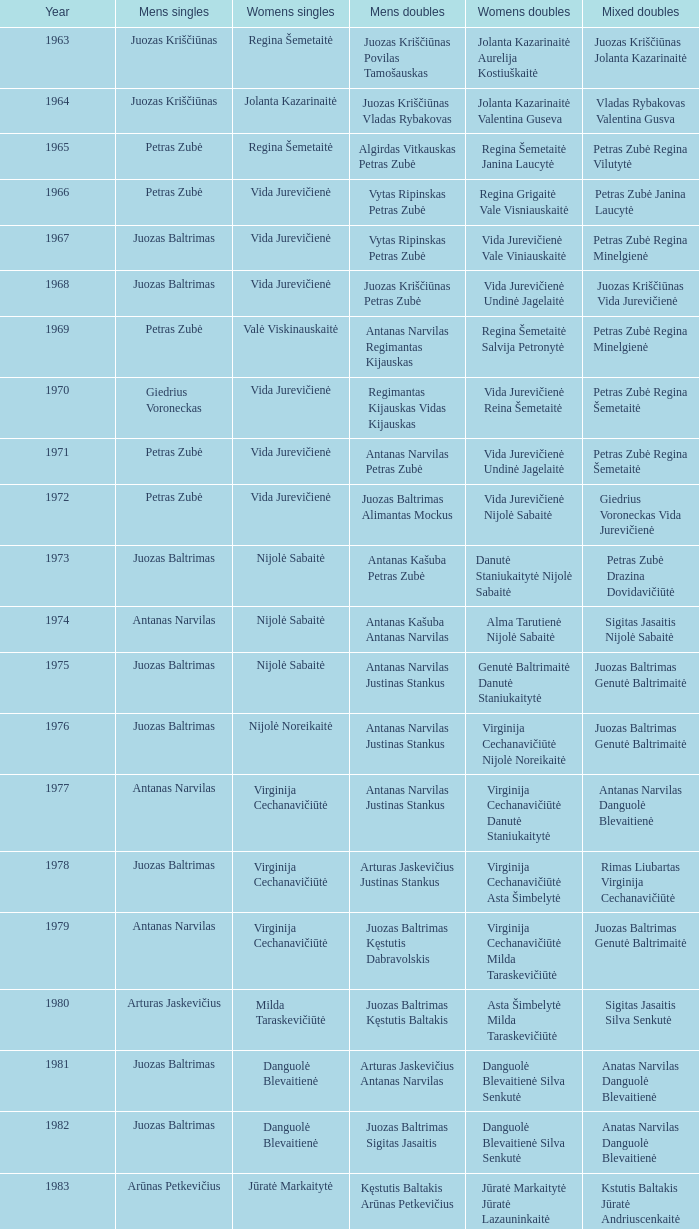In which year did the lithuanian national badminton championships commence? 1963.0. Can you give me this table as a dict? {'header': ['Year', 'Mens singles', 'Womens singles', 'Mens doubles', 'Womens doubles', 'Mixed doubles'], 'rows': [['1963', 'Juozas Kriščiūnas', 'Regina Šemetaitė', 'Juozas Kriščiūnas Povilas Tamošauskas', 'Jolanta Kazarinaitė Aurelija Kostiuškaitė', 'Juozas Kriščiūnas Jolanta Kazarinaitė'], ['1964', 'Juozas Kriščiūnas', 'Jolanta Kazarinaitė', 'Juozas Kriščiūnas Vladas Rybakovas', 'Jolanta Kazarinaitė Valentina Guseva', 'Vladas Rybakovas Valentina Gusva'], ['1965', 'Petras Zubė', 'Regina Šemetaitė', 'Algirdas Vitkauskas Petras Zubė', 'Regina Šemetaitė Janina Laucytė', 'Petras Zubė Regina Vilutytė'], ['1966', 'Petras Zubė', 'Vida Jurevičienė', 'Vytas Ripinskas Petras Zubė', 'Regina Grigaitė Vale Visniauskaitė', 'Petras Zubė Janina Laucytė'], ['1967', 'Juozas Baltrimas', 'Vida Jurevičienė', 'Vytas Ripinskas Petras Zubė', 'Vida Jurevičienė Vale Viniauskaitė', 'Petras Zubė Regina Minelgienė'], ['1968', 'Juozas Baltrimas', 'Vida Jurevičienė', 'Juozas Kriščiūnas Petras Zubė', 'Vida Jurevičienė Undinė Jagelaitė', 'Juozas Kriščiūnas Vida Jurevičienė'], ['1969', 'Petras Zubė', 'Valė Viskinauskaitė', 'Antanas Narvilas Regimantas Kijauskas', 'Regina Šemetaitė Salvija Petronytė', 'Petras Zubė Regina Minelgienė'], ['1970', 'Giedrius Voroneckas', 'Vida Jurevičienė', 'Regimantas Kijauskas Vidas Kijauskas', 'Vida Jurevičienė Reina Šemetaitė', 'Petras Zubė Regina Šemetaitė'], ['1971', 'Petras Zubė', 'Vida Jurevičienė', 'Antanas Narvilas Petras Zubė', 'Vida Jurevičienė Undinė Jagelaitė', 'Petras Zubė Regina Šemetaitė'], ['1972', 'Petras Zubė', 'Vida Jurevičienė', 'Juozas Baltrimas Alimantas Mockus', 'Vida Jurevičienė Nijolė Sabaitė', 'Giedrius Voroneckas Vida Jurevičienė'], ['1973', 'Juozas Baltrimas', 'Nijolė Sabaitė', 'Antanas Kašuba Petras Zubė', 'Danutė Staniukaitytė Nijolė Sabaitė', 'Petras Zubė Drazina Dovidavičiūtė'], ['1974', 'Antanas Narvilas', 'Nijolė Sabaitė', 'Antanas Kašuba Antanas Narvilas', 'Alma Tarutienė Nijolė Sabaitė', 'Sigitas Jasaitis Nijolė Sabaitė'], ['1975', 'Juozas Baltrimas', 'Nijolė Sabaitė', 'Antanas Narvilas Justinas Stankus', 'Genutė Baltrimaitė Danutė Staniukaitytė', 'Juozas Baltrimas Genutė Baltrimaitė'], ['1976', 'Juozas Baltrimas', 'Nijolė Noreikaitė', 'Antanas Narvilas Justinas Stankus', 'Virginija Cechanavičiūtė Nijolė Noreikaitė', 'Juozas Baltrimas Genutė Baltrimaitė'], ['1977', 'Antanas Narvilas', 'Virginija Cechanavičiūtė', 'Antanas Narvilas Justinas Stankus', 'Virginija Cechanavičiūtė Danutė Staniukaitytė', 'Antanas Narvilas Danguolė Blevaitienė'], ['1978', 'Juozas Baltrimas', 'Virginija Cechanavičiūtė', 'Arturas Jaskevičius Justinas Stankus', 'Virginija Cechanavičiūtė Asta Šimbelytė', 'Rimas Liubartas Virginija Cechanavičiūtė'], ['1979', 'Antanas Narvilas', 'Virginija Cechanavičiūtė', 'Juozas Baltrimas Kęstutis Dabravolskis', 'Virginija Cechanavičiūtė Milda Taraskevičiūtė', 'Juozas Baltrimas Genutė Baltrimaitė'], ['1980', 'Arturas Jaskevičius', 'Milda Taraskevičiūtė', 'Juozas Baltrimas Kęstutis Baltakis', 'Asta Šimbelytė Milda Taraskevičiūtė', 'Sigitas Jasaitis Silva Senkutė'], ['1981', 'Juozas Baltrimas', 'Danguolė Blevaitienė', 'Arturas Jaskevičius Antanas Narvilas', 'Danguolė Blevaitienė Silva Senkutė', 'Anatas Narvilas Danguolė Blevaitienė'], ['1982', 'Juozas Baltrimas', 'Danguolė Blevaitienė', 'Juozas Baltrimas Sigitas Jasaitis', 'Danguolė Blevaitienė Silva Senkutė', 'Anatas Narvilas Danguolė Blevaitienė'], ['1983', 'Arūnas Petkevičius', 'Jūratė Markaitytė', 'Kęstutis Baltakis Arūnas Petkevičius', 'Jūratė Markaitytė Jūratė Lazauninkaitė', 'Kstutis Baltakis Jūratė Andriuscenkaitė'], ['1984', 'Arūnas Petkevičius', 'Jūratė Markaitytė', 'Kęstutis Baltakis Arūnas Petkevičius', 'Jūratė Markaitytė Edita Andriuscenkaitė', 'Arūnas Petkevičius Jūratė Markaitytė'], ['1985', 'Arūnas Petkevičius', 'Jūratė Markaitytė', 'Kęstutis Baltakis Arūnas Petkevičius', 'Jūratė Markaitytė Silva Senkutė', 'Arūnas Petkevičius Jūratė Markaitytė'], ['1986', 'Arūnas Petkevičius', 'Jūratė Markaitytė', 'Kęstutis Baltakis Arūnas Petkevičius', 'Jūratė Markaitytė Aušrinė Gebranaitė', 'Egidijus Jankauskas Jūratė Markaitytė'], ['1987', 'Egidijus Jankauskas', 'Jūratė Markaitytė', 'Kęstutis Baltakis Arūnas Petkevičius', 'Jūratė Markaitytė Danguolė Blevaitienė', 'Egidijus Jankauskas Danguolė Blevaitienė'], ['1988', 'Arūnas Petkevičius', 'Rasa Mikšytė', 'Algirdas Kepežinskas Ovidius Česonis', 'Jūratė Markaitytė Danguolė Blevaitienė', 'Arūnas Petkevičius Danguolė Blevaitienė'], ['1989', 'Ovidijus Cesonis', 'Aušrinė Gabrenaitė', 'Egidijus Jankauskus Ovidius Česonis', 'Aušrinė Gebranaitė Rasa Mikšytė', 'Egidijus Jankauskas Aušrinė Gabrenaitė'], ['1990', 'Aivaras Kvedarauskas', 'Rasa Mikšytė', 'Algirdas Kepežinskas Ovidius Česonis', 'Jūratė Markaitytė Danguolė Blevaitienė', 'Aivaras Kvedarauskas Rasa Mikšytė'], ['1991', 'Egidius Jankauskas', 'Rasa Mikšytė', 'Egidijus Jankauskus Ovidius Česonis', 'Rasa Mikšytė Solveiga Stasaitytė', 'Algirdas Kepežinskas Rasa Mikšytė'], ['1992', 'Egidius Jankauskas', 'Rasa Mikšytė', 'Aivaras Kvedarauskas Vygandas Virzintas', 'Rasa Mikšytė Solveiga Stasaitytė', 'Algirdas Kepežinskas Rasa Mikšytė'], ['1993', 'Edigius Jankauskas', 'Solveiga Stasaitytė', 'Edigius Jankauskas Aivaras Kvedarauskas', 'Rasa Mikšytė Solveiga Stasaitytė', 'Edigius Jankauskas Solveiga Stasaitytė'], ['1994', 'Aivaras Kvedarauskas', 'Aina Kravtienė', 'Aivaras Kvedarauskas Ovidijus Zukauskas', 'Indre Ivanauskaitė Rasa Mikšytė', 'Aivaras Kvedarauskas Indze Ivanauskaitė'], ['1995', 'Aivaras Kvedarauskas', 'Rasa Mikšytė', 'Algirdas Kepežinskas Aivaras Kvedarauskas', 'Indre Ivanauskaitė Rasa Mikšytė', 'Aivaras Kvedarauskas Rasa Mikšytė'], ['1996', 'Aivaras Kvedarauskas', 'Rasa Myksite', 'Aivaras Kvedarauskas Donatas Vievesis', 'Indre Ivanauskaitė Rasa Mikšytė', 'Aivaras Kvedarauskas Rasa Mikšytė'], ['1997', 'Aivaras Kvedarauskas', 'Rasa Myksite', 'Aivaras Kvedarauskas Gediminas Andrikonis', 'Neringa Karosaitė Aina Kravtienė', 'Aivaras Kvedarauskas Rasa Mikšytė'], ['1998', 'Aivaras Kvedarauskas', 'Neringa Karosaitė', 'Aivaras Kvedarauskas Dainius Mikalauskas', 'Rasa Mikšytė Jūratė Prevelienė', 'Aivaras Kvedarauskas Jūratė Prevelienė'], ['1999', 'Aivaras Kvedarauskas', 'Erika Milikauskaitė', 'Aivaras Kvedarauskas Dainius Mikalauskas', 'Rasa Mikšytė Jūratė Prevelienė', 'Aivaras Kvedarauskas Rasa Mikšytė'], ['2000', 'Aivaras Kvedarauskas', 'Erika Milikauskaitė', 'Aivaras Kvedarauskas Donatas Vievesis', 'Kristina Dovidaitytė Neringa Karosaitė', 'Aivaras Kvedarauskas Jūratė Prevelienė'], ['2001', 'Aivaras Kvedarauskas', 'Neringa Karosaitė', 'Aivaras Kvedarauskas Juozas Spelveris', 'Kristina Dovidaitytė Neringa Karosaitė', 'Aivaras Kvedarauskas Ligita Zakauskaitė'], ['2002', 'Aivaras Kvedarauskas', 'Erika Milikauskaitė', 'Aivaras Kvedarauskas Kęstutis Navickas', 'Kristina Dovidaitytė Neringa Karosaitė', 'Aivaras Kvedarauskas Jūratė Prevelienė'], ['2003', 'Aivaras Kvedarauskas', 'Ugnė Urbonaitė', 'Aivaras Kvedarauskas Dainius Mikalauskas', 'Ugnė Urbonaitė Kristina Dovidaitytė', 'Aivaras Kvedarauskas Ugnė Urbonaitė'], ['2004', 'Kęstutis Navickas', 'Ugnė Urbonaitė', 'Kęstutis Navickas Klaudijus Kasinskis', 'Ugnė Urbonaitė Akvilė Stapušaitytė', 'Kęstutis Navickas Ugnė Urbonaitė'], ['2005', 'Kęstutis Navickas', 'Ugnė Urbonaitė', 'Kęstutis Navickas Klaudijus Kasinskis', 'Ugnė Urbonaitė Akvilė Stapušaitytė', 'Donatas Narvilas Kristina Dovidaitytė'], ['2006', 'Šarūnas Bilius', 'Akvilė Stapušaitytė', 'Deividas Butkus Klaudijus Kašinskis', 'Akvilė Stapušaitytė Ligita Žukauskaitė', 'Donatas Narvilas Kristina Dovidaitytė'], ['2007', 'Kęstutis Navickas', 'Akvilė Stapušaitytė', 'Kęstutis Navickas Klaudijus Kašinskis', 'Gerda Voitechovskaja Kristina Dovidaitytė', 'Kęstutis Navickas Indrė Starevičiūtė'], ['2008', 'Kęstutis Navickas', 'Akvilė Stapušaitytė', 'Paulius Geležiūnas Ramūnas Stapušaitis', 'Gerda Voitechovskaja Kristina Dovidaitytė', 'Kęstutis Navickas Akvilė Stapušaitytė'], ['2009', 'Kęstutis Navickas', 'Akvilė Stapušaitytė', 'Kęstutis Navickas Klaudijus Kašinskis', 'Akvilė Stapušaitytė Ligita Žukauskaitė', 'Kęstutis Navickas Akvilė Stapušaitytė']]} 